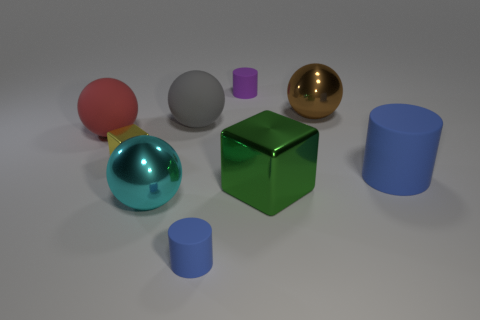Is there a rubber object that has the same color as the big cylinder?
Offer a very short reply. Yes. There is a large cylinder; does it have the same color as the cylinder that is in front of the large blue object?
Make the answer very short. Yes. There is a small thing that is in front of the yellow thing; is its color the same as the large matte cylinder?
Give a very brief answer. Yes. There is a blue thing that is behind the large cyan metallic ball that is to the left of the metal ball that is on the right side of the large cyan thing; what is its material?
Keep it short and to the point. Rubber. How many purple cylinders have the same material as the large blue object?
Offer a very short reply. 1. What is the shape of the small matte thing that is the same color as the big cylinder?
Keep it short and to the point. Cylinder. There is a green object that is the same size as the brown ball; what is its shape?
Provide a short and direct response. Cube. What material is the small cylinder that is the same color as the large cylinder?
Your answer should be compact. Rubber. Are there any large green metal things in front of the small yellow metal thing?
Offer a very short reply. Yes. Are there any other large red objects that have the same shape as the large red rubber object?
Ensure brevity in your answer.  No. 